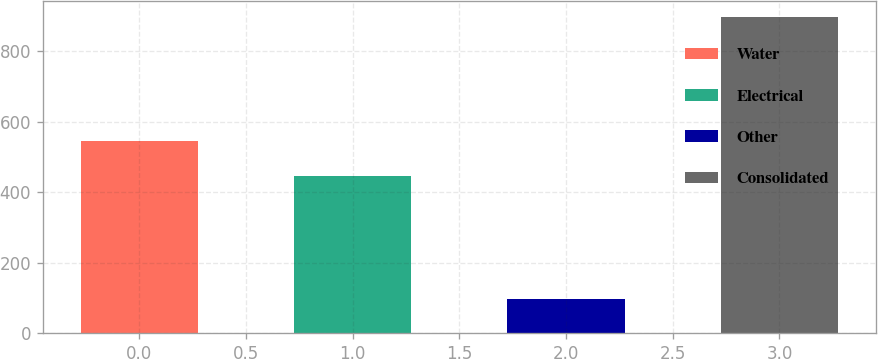<chart> <loc_0><loc_0><loc_500><loc_500><bar_chart><fcel>Water<fcel>Electrical<fcel>Other<fcel>Consolidated<nl><fcel>546<fcel>447<fcel>95.8<fcel>897.2<nl></chart> 